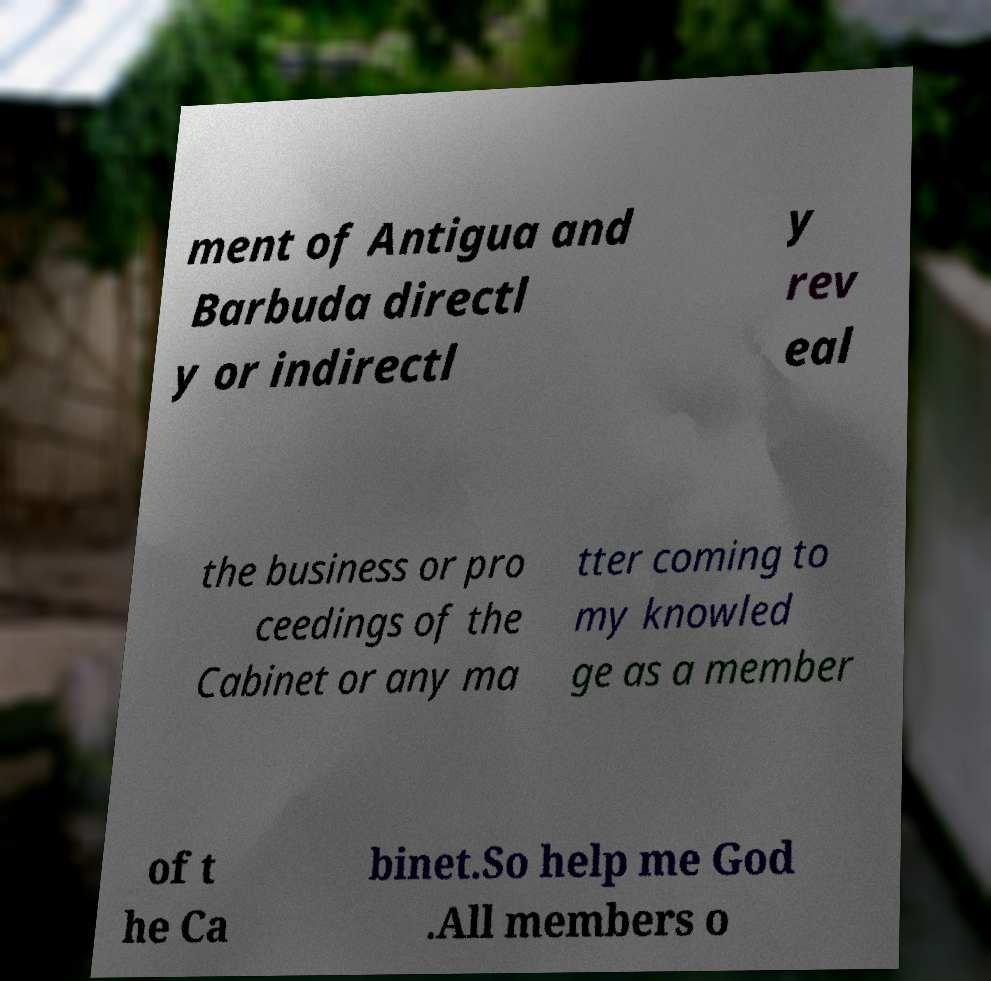I need the written content from this picture converted into text. Can you do that? ment of Antigua and Barbuda directl y or indirectl y rev eal the business or pro ceedings of the Cabinet or any ma tter coming to my knowled ge as a member of t he Ca binet.So help me God .All members o 